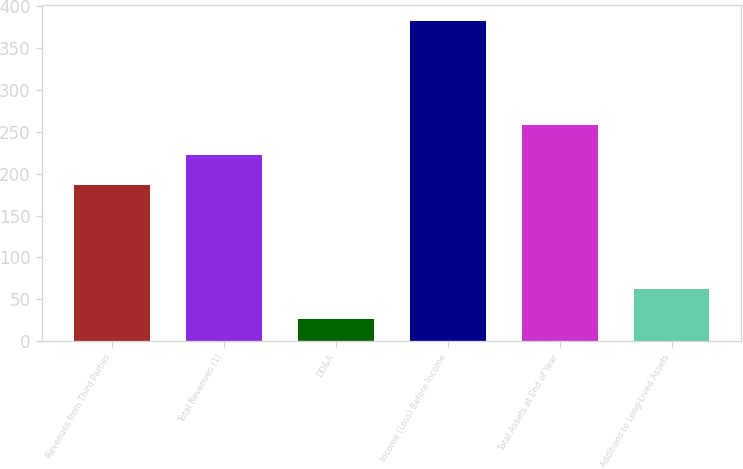<chart> <loc_0><loc_0><loc_500><loc_500><bar_chart><fcel>Revenues from Third Parties<fcel>Total Revenues (1)<fcel>DD&A<fcel>Income (Loss) Before Income<fcel>Total Assets at End of Year<fcel>Additions to Long-Lived Assets<nl><fcel>187<fcel>222.7<fcel>26<fcel>383<fcel>258.4<fcel>61.7<nl></chart> 